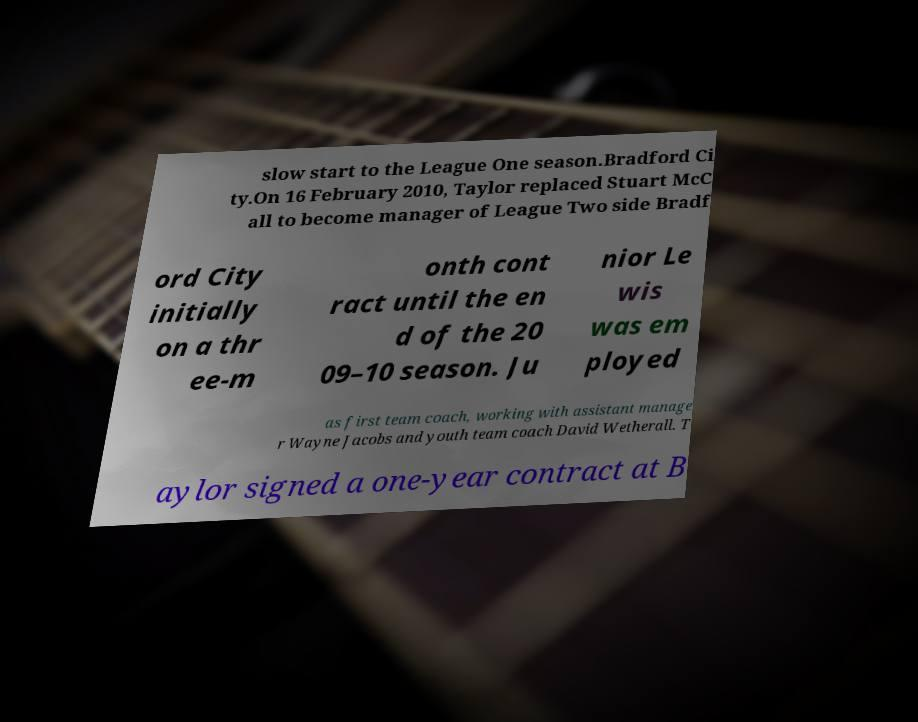Please read and relay the text visible in this image. What does it say? slow start to the League One season.Bradford Ci ty.On 16 February 2010, Taylor replaced Stuart McC all to become manager of League Two side Bradf ord City initially on a thr ee-m onth cont ract until the en d of the 20 09–10 season. Ju nior Le wis was em ployed as first team coach, working with assistant manage r Wayne Jacobs and youth team coach David Wetherall. T aylor signed a one-year contract at B 